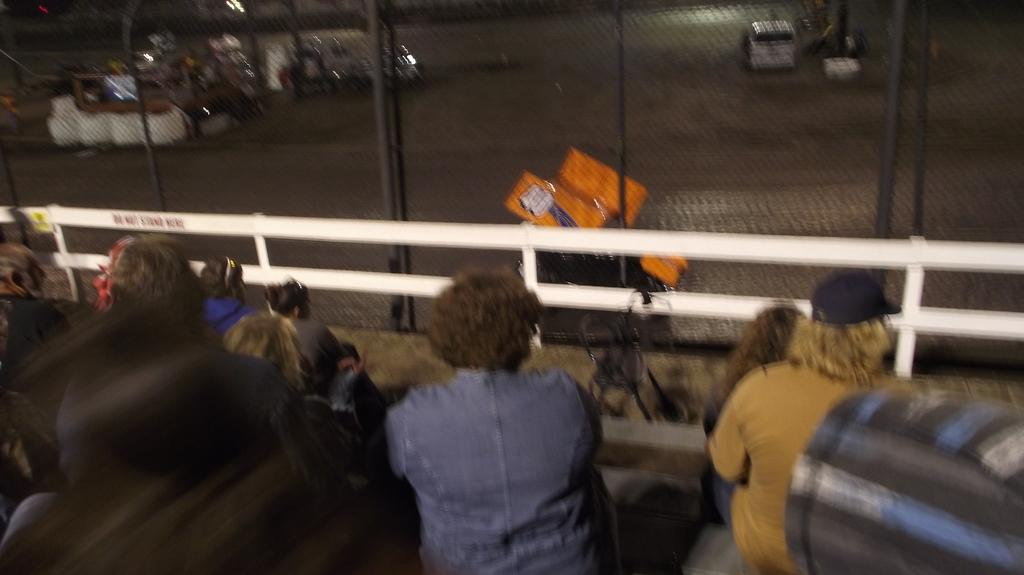What are the people in the image doing? There is a group of people sitting in the image. What are the people sitting on? There are chairs in the image. What can be seen in the background of the image? Vehicles are visible on the road in the background of the image. What type of barrier is present in the image? There are fences in the image. What type of poison is being used by the people in the image? There is no poison present in the image; the people are simply sitting. 